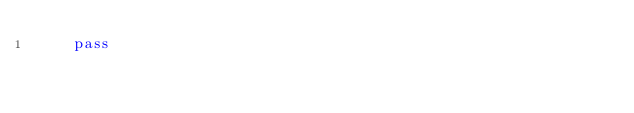<code> <loc_0><loc_0><loc_500><loc_500><_Python_>    pass
</code> 